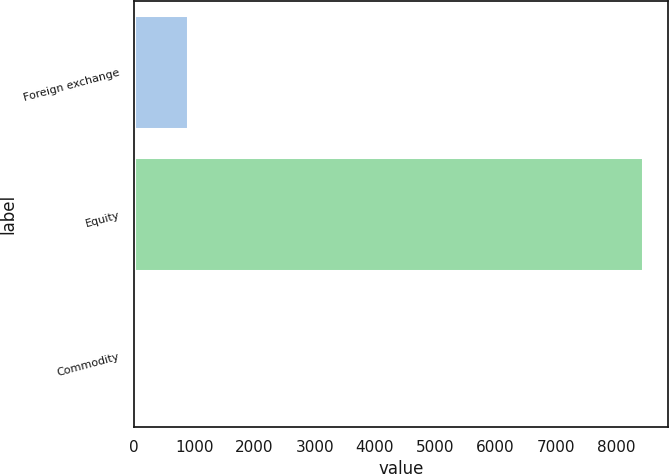<chart> <loc_0><loc_0><loc_500><loc_500><bar_chart><fcel>Foreign exchange<fcel>Equity<fcel>Commodity<nl><fcel>889.7<fcel>8447<fcel>50<nl></chart> 